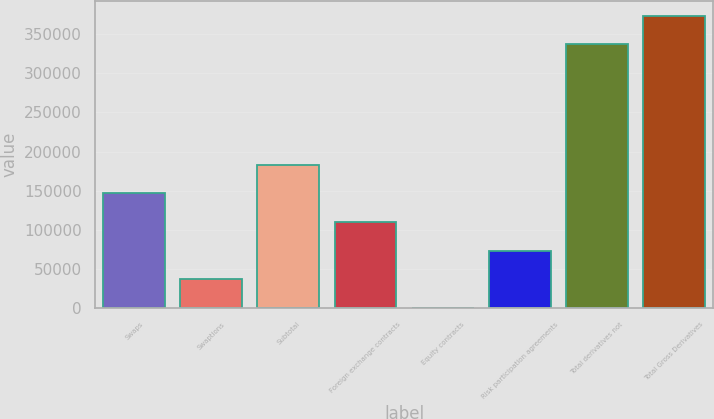Convert chart. <chart><loc_0><loc_0><loc_500><loc_500><bar_chart><fcel>Swaps<fcel>Swaptions<fcel>Subtotal<fcel>Foreign exchange contracts<fcel>Equity contracts<fcel>Risk participation agreements<fcel>Total derivatives not<fcel>Total Gross Derivatives<nl><fcel>146605<fcel>36730.1<fcel>183230<fcel>109980<fcel>105<fcel>73355.2<fcel>337086<fcel>373711<nl></chart> 